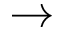Convert formula to latex. <formula><loc_0><loc_0><loc_500><loc_500>\rightarrow</formula> 